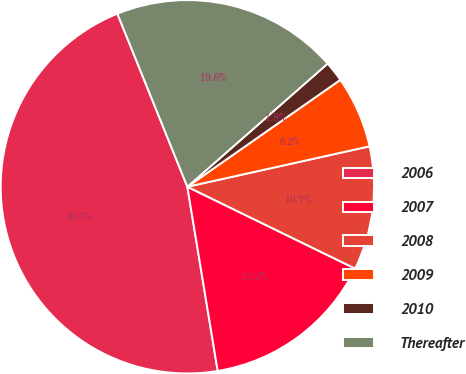<chart> <loc_0><loc_0><loc_500><loc_500><pie_chart><fcel>2006<fcel>2007<fcel>2008<fcel>2009<fcel>2010<fcel>Thereafter<nl><fcel>46.49%<fcel>15.18%<fcel>10.7%<fcel>6.23%<fcel>1.76%<fcel>19.65%<nl></chart> 